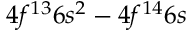<formula> <loc_0><loc_0><loc_500><loc_500>4 f ^ { 1 3 } 6 s ^ { 2 } - 4 f ^ { 1 4 } 6 s</formula> 